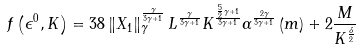<formula> <loc_0><loc_0><loc_500><loc_500>f \left ( \epsilon ^ { 0 } , K \right ) = 3 8 \left \| X _ { 1 } \right \| _ { \gamma } ^ { \frac { \gamma } { 3 \gamma + 1 } } L ^ { \frac { \gamma } { 3 \gamma + 1 } } K ^ { \frac { \frac { 5 } { 2 } \gamma + 1 } { 3 \gamma + 1 } } \alpha ^ { \frac { 2 \gamma } { 3 \gamma + 1 } } \left ( m \right ) + 2 \frac { M } { K ^ { \frac { \delta } { 2 } } }</formula> 